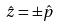<formula> <loc_0><loc_0><loc_500><loc_500>\hat { z } = \pm \hat { p }</formula> 